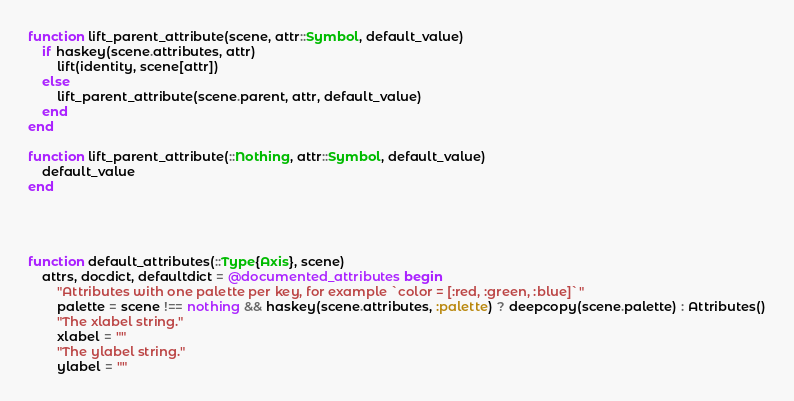Convert code to text. <code><loc_0><loc_0><loc_500><loc_500><_Julia_>function lift_parent_attribute(scene, attr::Symbol, default_value)
    if haskey(scene.attributes, attr)
        lift(identity, scene[attr])
    else
        lift_parent_attribute(scene.parent, attr, default_value)
    end
end

function lift_parent_attribute(::Nothing, attr::Symbol, default_value)
    default_value
end




function default_attributes(::Type{Axis}, scene)
    attrs, docdict, defaultdict = @documented_attributes begin
        "Attributes with one palette per key, for example `color = [:red, :green, :blue]`"
        palette = scene !== nothing && haskey(scene.attributes, :palette) ? deepcopy(scene.palette) : Attributes()
        "The xlabel string."
        xlabel = ""
        "The ylabel string."
        ylabel = ""</code> 